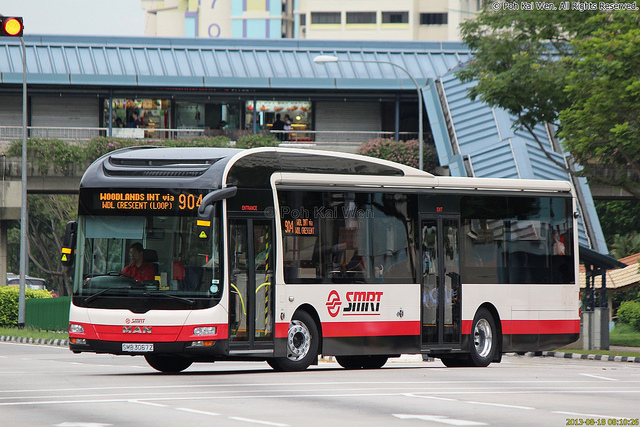Identify and read out the text in this image. WOODLANDS INT 904 CRESCENT Reserved Wen FOR SMRT Kai Poh M A N LOOP via 